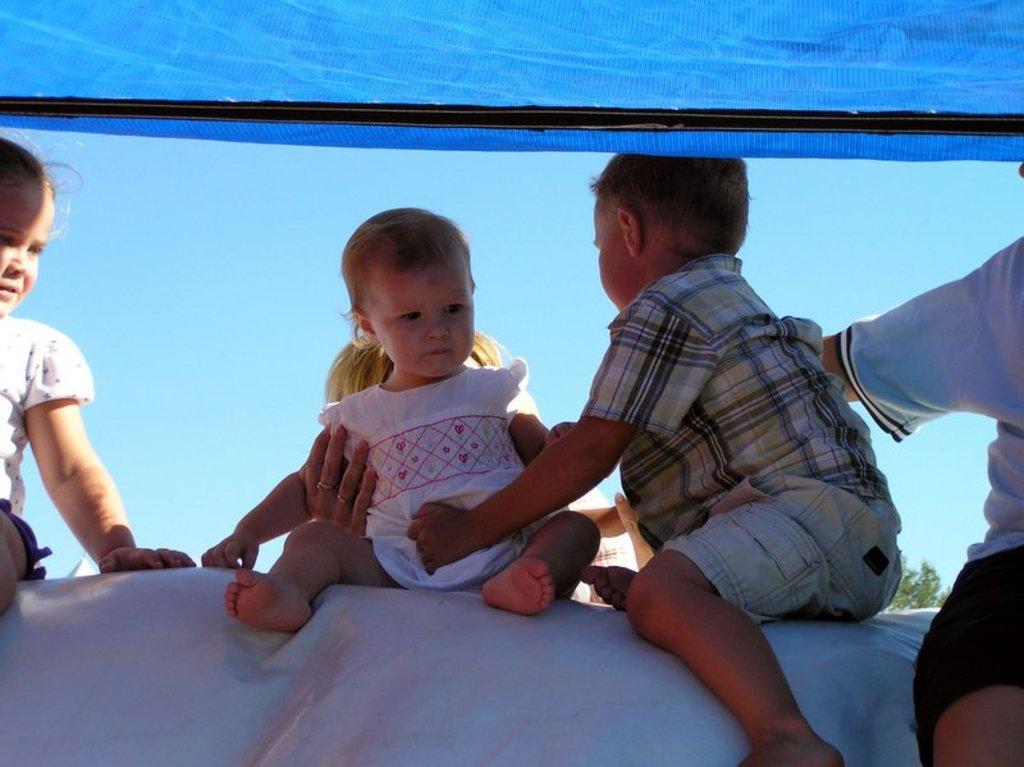What are the kids sitting on in the image? The kids are sitting on a white color object in the image. What is the woman doing in the image? The woman is holding a small kid at the middle. What can be seen in the background of the image? The background of the image includes a blue color sky. What type of match is being played by the kids in the image? There is no match being played in the image; the kids are simply sitting on a white color object. Can you see any clams in the image? There are no clams present in the image. 